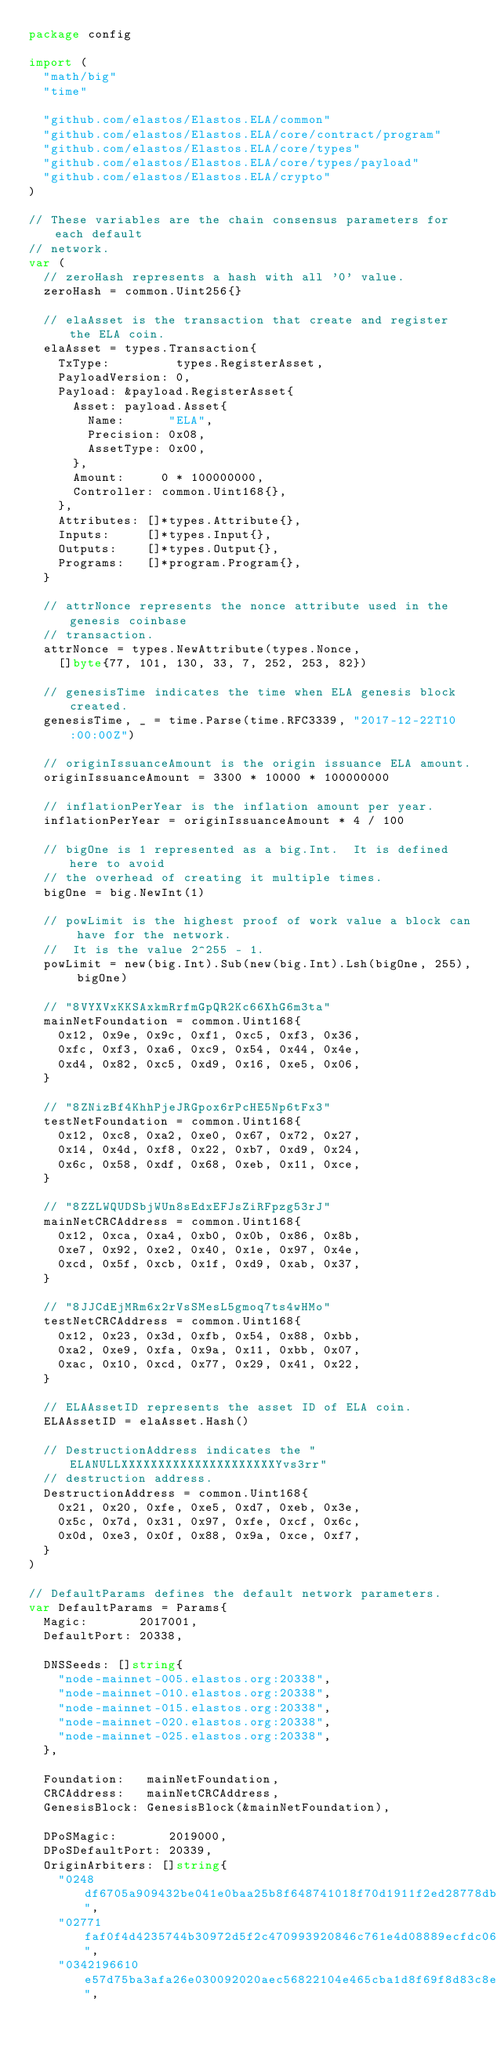<code> <loc_0><loc_0><loc_500><loc_500><_Go_>package config

import (
	"math/big"
	"time"

	"github.com/elastos/Elastos.ELA/common"
	"github.com/elastos/Elastos.ELA/core/contract/program"
	"github.com/elastos/Elastos.ELA/core/types"
	"github.com/elastos/Elastos.ELA/core/types/payload"
	"github.com/elastos/Elastos.ELA/crypto"
)

// These variables are the chain consensus parameters for each default
// network.
var (
	// zeroHash represents a hash with all '0' value.
	zeroHash = common.Uint256{}

	// elaAsset is the transaction that create and register the ELA coin.
	elaAsset = types.Transaction{
		TxType:         types.RegisterAsset,
		PayloadVersion: 0,
		Payload: &payload.RegisterAsset{
			Asset: payload.Asset{
				Name:      "ELA",
				Precision: 0x08,
				AssetType: 0x00,
			},
			Amount:     0 * 100000000,
			Controller: common.Uint168{},
		},
		Attributes: []*types.Attribute{},
		Inputs:     []*types.Input{},
		Outputs:    []*types.Output{},
		Programs:   []*program.Program{},
	}

	// attrNonce represents the nonce attribute used in the genesis coinbase
	// transaction.
	attrNonce = types.NewAttribute(types.Nonce,
		[]byte{77, 101, 130, 33, 7, 252, 253, 82})

	// genesisTime indicates the time when ELA genesis block created.
	genesisTime, _ = time.Parse(time.RFC3339, "2017-12-22T10:00:00Z")

	// originIssuanceAmount is the origin issuance ELA amount.
	originIssuanceAmount = 3300 * 10000 * 100000000

	// inflationPerYear is the inflation amount per year.
	inflationPerYear = originIssuanceAmount * 4 / 100

	// bigOne is 1 represented as a big.Int.  It is defined here to avoid
	// the overhead of creating it multiple times.
	bigOne = big.NewInt(1)

	// powLimit is the highest proof of work value a block can have for the network.
	//  It is the value 2^255 - 1.
	powLimit = new(big.Int).Sub(new(big.Int).Lsh(bigOne, 255), bigOne)

	// "8VYXVxKKSAxkmRrfmGpQR2Kc66XhG6m3ta"
	mainNetFoundation = common.Uint168{
		0x12, 0x9e, 0x9c, 0xf1, 0xc5, 0xf3, 0x36,
		0xfc, 0xf3, 0xa6, 0xc9, 0x54, 0x44, 0x4e,
		0xd4, 0x82, 0xc5, 0xd9, 0x16, 0xe5, 0x06,
	}

	// "8ZNizBf4KhhPjeJRGpox6rPcHE5Np6tFx3"
	testNetFoundation = common.Uint168{
		0x12, 0xc8, 0xa2, 0xe0, 0x67, 0x72, 0x27,
		0x14, 0x4d, 0xf8, 0x22, 0xb7, 0xd9, 0x24,
		0x6c, 0x58, 0xdf, 0x68, 0xeb, 0x11, 0xce,
	}

	// "8ZZLWQUDSbjWUn8sEdxEFJsZiRFpzg53rJ"
	mainNetCRCAddress = common.Uint168{
		0x12, 0xca, 0xa4, 0xb0, 0x0b, 0x86, 0x8b,
		0xe7, 0x92, 0xe2, 0x40, 0x1e, 0x97, 0x4e,
		0xcd, 0x5f, 0xcb, 0x1f, 0xd9, 0xab, 0x37,
	}

	// "8JJCdEjMRm6x2rVsSMesL5gmoq7ts4wHMo"
	testNetCRCAddress = common.Uint168{
		0x12, 0x23, 0x3d, 0xfb, 0x54, 0x88, 0xbb,
		0xa2, 0xe9, 0xfa, 0x9a, 0x11, 0xbb, 0x07,
		0xac, 0x10, 0xcd, 0x77, 0x29, 0x41, 0x22,
	}

	// ELAAssetID represents the asset ID of ELA coin.
	ELAAssetID = elaAsset.Hash()

	// DestructionAddress indicates the "ELANULLXXXXXXXXXXXXXXXXXXXXXYvs3rr"
	// destruction address.
	DestructionAddress = common.Uint168{
		0x21, 0x20, 0xfe, 0xe5, 0xd7, 0xeb, 0x3e,
		0x5c, 0x7d, 0x31, 0x97, 0xfe, 0xcf, 0x6c,
		0x0d, 0xe3, 0x0f, 0x88, 0x9a, 0xce, 0xf7,
	}
)

// DefaultParams defines the default network parameters.
var DefaultParams = Params{
	Magic:       2017001,
	DefaultPort: 20338,

	DNSSeeds: []string{
		"node-mainnet-005.elastos.org:20338",
		"node-mainnet-010.elastos.org:20338",
		"node-mainnet-015.elastos.org:20338",
		"node-mainnet-020.elastos.org:20338",
		"node-mainnet-025.elastos.org:20338",
	},

	Foundation:   mainNetFoundation,
	CRCAddress:   mainNetCRCAddress,
	GenesisBlock: GenesisBlock(&mainNetFoundation),

	DPoSMagic:       2019000,
	DPoSDefaultPort: 20339,
	OriginArbiters: []string{
		"0248df6705a909432be041e0baa25b8f648741018f70d1911f2ed28778db4b8fe4",
		"02771faf0f4d4235744b30972d5f2c470993920846c761e4d08889ecfdc061cddf",
		"0342196610e57d75ba3afa26e030092020aec56822104e465cba1d8f69f8d83c8e",</code> 